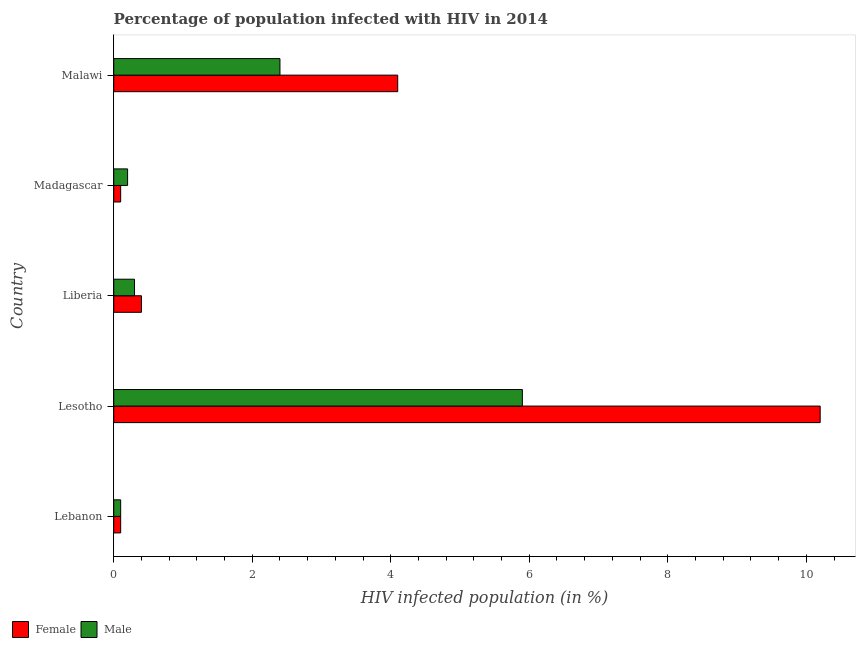How many different coloured bars are there?
Ensure brevity in your answer.  2. What is the label of the 4th group of bars from the top?
Provide a succinct answer. Lesotho. In how many cases, is the number of bars for a given country not equal to the number of legend labels?
Provide a succinct answer. 0. Across all countries, what is the maximum percentage of males who are infected with hiv?
Give a very brief answer. 5.9. In which country was the percentage of males who are infected with hiv maximum?
Make the answer very short. Lesotho. In which country was the percentage of females who are infected with hiv minimum?
Offer a terse response. Lebanon. What is the total percentage of males who are infected with hiv in the graph?
Your answer should be compact. 8.9. What is the difference between the percentage of females who are infected with hiv in Liberia and that in Malawi?
Offer a very short reply. -3.7. What is the difference between the percentage of males who are infected with hiv in Lebanon and the percentage of females who are infected with hiv in Malawi?
Ensure brevity in your answer.  -4. What is the average percentage of males who are infected with hiv per country?
Offer a terse response. 1.78. What is the ratio of the percentage of males who are infected with hiv in Madagascar to that in Malawi?
Offer a terse response. 0.08. Is the percentage of males who are infected with hiv in Liberia less than that in Malawi?
Ensure brevity in your answer.  Yes. Is the difference between the percentage of males who are infected with hiv in Liberia and Madagascar greater than the difference between the percentage of females who are infected with hiv in Liberia and Madagascar?
Your answer should be compact. No. In how many countries, is the percentage of males who are infected with hiv greater than the average percentage of males who are infected with hiv taken over all countries?
Offer a very short reply. 2. What does the 2nd bar from the top in Madagascar represents?
Make the answer very short. Female. What does the 1st bar from the bottom in Madagascar represents?
Offer a very short reply. Female. How many countries are there in the graph?
Make the answer very short. 5. Are the values on the major ticks of X-axis written in scientific E-notation?
Make the answer very short. No. Does the graph contain any zero values?
Your answer should be compact. No. Where does the legend appear in the graph?
Give a very brief answer. Bottom left. How many legend labels are there?
Give a very brief answer. 2. What is the title of the graph?
Offer a very short reply. Percentage of population infected with HIV in 2014. Does "Constant 2005 US$" appear as one of the legend labels in the graph?
Your response must be concise. No. What is the label or title of the X-axis?
Your response must be concise. HIV infected population (in %). What is the label or title of the Y-axis?
Give a very brief answer. Country. What is the HIV infected population (in %) of Female in Lesotho?
Make the answer very short. 10.2. What is the HIV infected population (in %) of Male in Liberia?
Provide a short and direct response. 0.3. Across all countries, what is the maximum HIV infected population (in %) in Female?
Your answer should be compact. 10.2. Across all countries, what is the minimum HIV infected population (in %) in Male?
Offer a very short reply. 0.1. What is the difference between the HIV infected population (in %) in Male in Lebanon and that in Lesotho?
Offer a very short reply. -5.8. What is the difference between the HIV infected population (in %) of Male in Lebanon and that in Liberia?
Provide a short and direct response. -0.2. What is the difference between the HIV infected population (in %) in Male in Lebanon and that in Madagascar?
Ensure brevity in your answer.  -0.1. What is the difference between the HIV infected population (in %) of Female in Lebanon and that in Malawi?
Your response must be concise. -4. What is the difference between the HIV infected population (in %) of Male in Lebanon and that in Malawi?
Your answer should be very brief. -2.3. What is the difference between the HIV infected population (in %) in Female in Lesotho and that in Liberia?
Your answer should be compact. 9.8. What is the difference between the HIV infected population (in %) of Male in Lesotho and that in Liberia?
Offer a very short reply. 5.6. What is the difference between the HIV infected population (in %) in Female in Lesotho and that in Malawi?
Your answer should be compact. 6.1. What is the difference between the HIV infected population (in %) of Male in Lesotho and that in Malawi?
Give a very brief answer. 3.5. What is the difference between the HIV infected population (in %) in Female in Lebanon and the HIV infected population (in %) in Male in Lesotho?
Provide a short and direct response. -5.8. What is the difference between the HIV infected population (in %) in Female in Lebanon and the HIV infected population (in %) in Male in Malawi?
Provide a short and direct response. -2.3. What is the difference between the HIV infected population (in %) of Female in Lesotho and the HIV infected population (in %) of Male in Malawi?
Provide a short and direct response. 7.8. What is the difference between the HIV infected population (in %) in Female in Liberia and the HIV infected population (in %) in Male in Malawi?
Ensure brevity in your answer.  -2. What is the average HIV infected population (in %) of Female per country?
Provide a short and direct response. 2.98. What is the average HIV infected population (in %) of Male per country?
Provide a succinct answer. 1.78. What is the difference between the HIV infected population (in %) in Female and HIV infected population (in %) in Male in Liberia?
Provide a short and direct response. 0.1. What is the difference between the HIV infected population (in %) of Female and HIV infected population (in %) of Male in Madagascar?
Make the answer very short. -0.1. What is the difference between the HIV infected population (in %) of Female and HIV infected population (in %) of Male in Malawi?
Give a very brief answer. 1.7. What is the ratio of the HIV infected population (in %) of Female in Lebanon to that in Lesotho?
Your response must be concise. 0.01. What is the ratio of the HIV infected population (in %) of Male in Lebanon to that in Lesotho?
Your answer should be compact. 0.02. What is the ratio of the HIV infected population (in %) in Male in Lebanon to that in Liberia?
Provide a succinct answer. 0.33. What is the ratio of the HIV infected population (in %) of Female in Lebanon to that in Malawi?
Your answer should be very brief. 0.02. What is the ratio of the HIV infected population (in %) in Male in Lebanon to that in Malawi?
Offer a very short reply. 0.04. What is the ratio of the HIV infected population (in %) of Female in Lesotho to that in Liberia?
Offer a very short reply. 25.5. What is the ratio of the HIV infected population (in %) of Male in Lesotho to that in Liberia?
Provide a short and direct response. 19.67. What is the ratio of the HIV infected population (in %) of Female in Lesotho to that in Madagascar?
Your answer should be compact. 102. What is the ratio of the HIV infected population (in %) of Male in Lesotho to that in Madagascar?
Ensure brevity in your answer.  29.5. What is the ratio of the HIV infected population (in %) of Female in Lesotho to that in Malawi?
Keep it short and to the point. 2.49. What is the ratio of the HIV infected population (in %) of Male in Lesotho to that in Malawi?
Your answer should be very brief. 2.46. What is the ratio of the HIV infected population (in %) in Male in Liberia to that in Madagascar?
Provide a succinct answer. 1.5. What is the ratio of the HIV infected population (in %) in Female in Liberia to that in Malawi?
Your response must be concise. 0.1. What is the ratio of the HIV infected population (in %) of Female in Madagascar to that in Malawi?
Your response must be concise. 0.02. What is the ratio of the HIV infected population (in %) in Male in Madagascar to that in Malawi?
Give a very brief answer. 0.08. What is the difference between the highest and the second highest HIV infected population (in %) in Male?
Provide a succinct answer. 3.5. What is the difference between the highest and the lowest HIV infected population (in %) of Female?
Give a very brief answer. 10.1. What is the difference between the highest and the lowest HIV infected population (in %) of Male?
Keep it short and to the point. 5.8. 